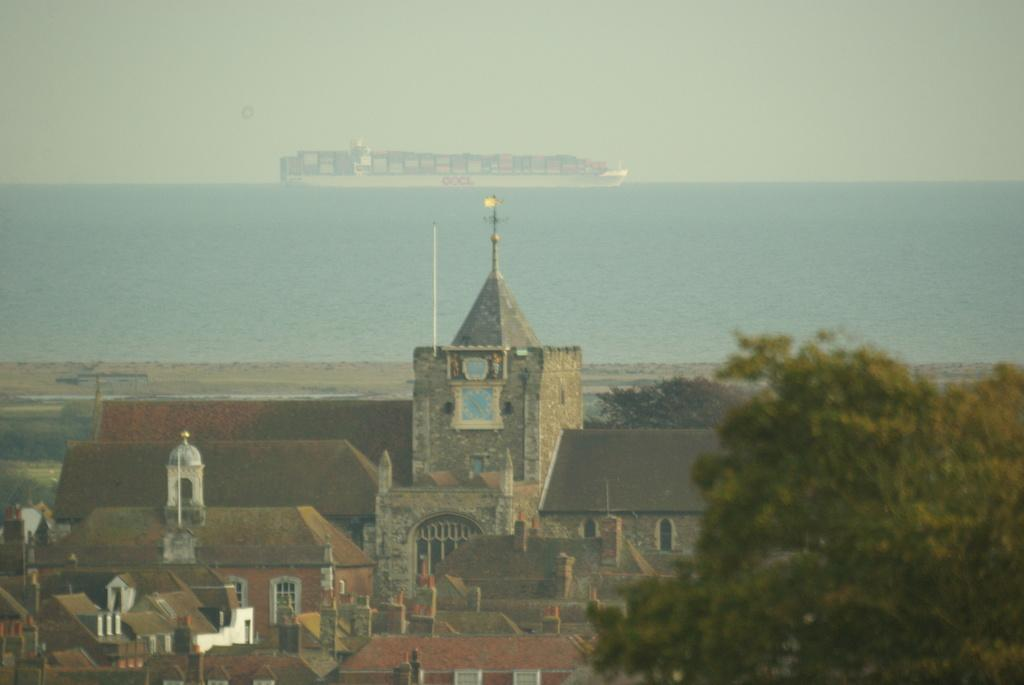What type of structures can be seen in the image? There are buildings in the image. What other natural elements are present in the image? There are trees in the image. What mode of transportation can be seen on the river in the image? There is a ship on a river in the image. What is visible part of the environment is not directly related to the buildings or trees? The sky is visible in the background of the image. What type of thing is causing the flame to burn brighter in the image? There is no flame present in the image, so this question cannot be answered. 